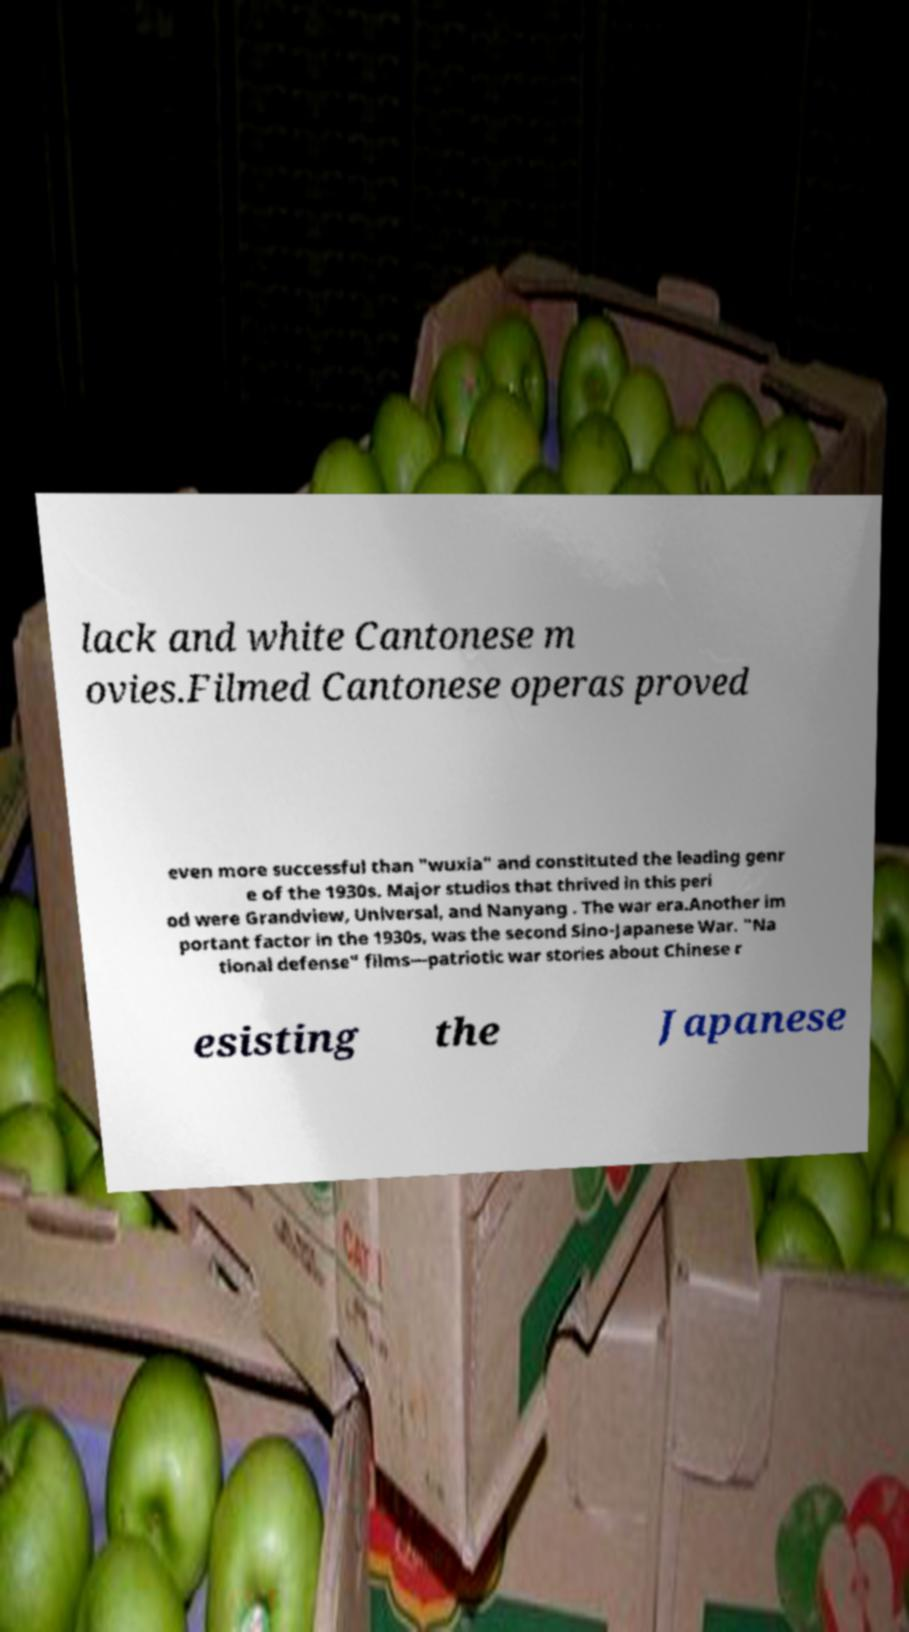Can you accurately transcribe the text from the provided image for me? lack and white Cantonese m ovies.Filmed Cantonese operas proved even more successful than "wuxia" and constituted the leading genr e of the 1930s. Major studios that thrived in this peri od were Grandview, Universal, and Nanyang . The war era.Another im portant factor in the 1930s, was the second Sino-Japanese War. "Na tional defense" films—patriotic war stories about Chinese r esisting the Japanese 